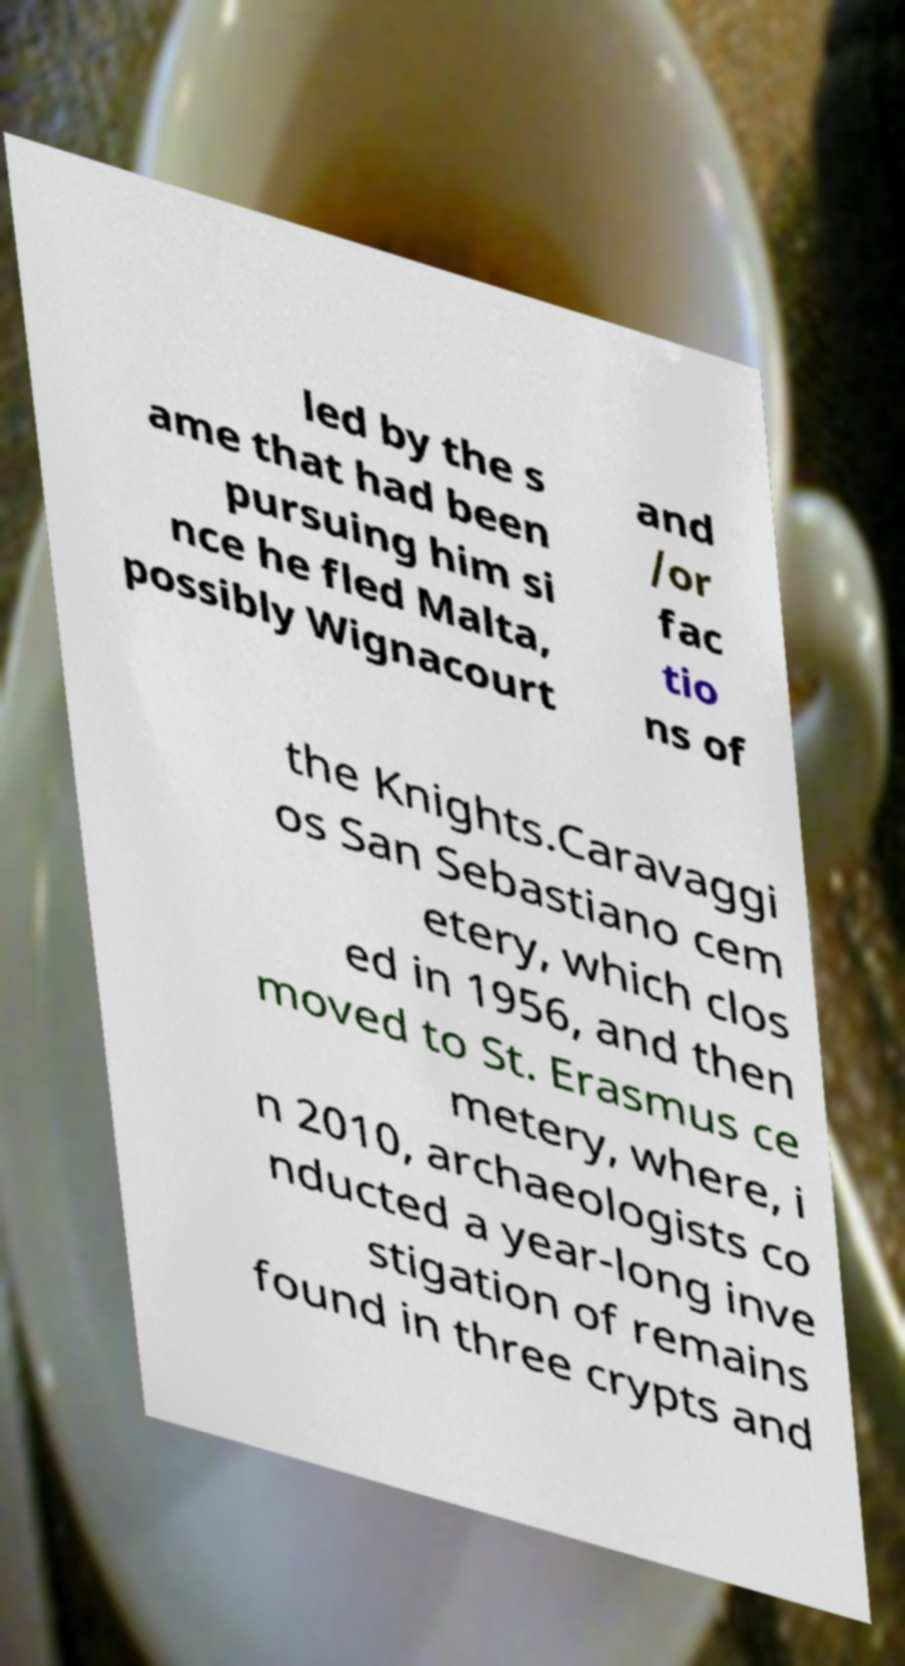Could you extract and type out the text from this image? led by the s ame that had been pursuing him si nce he fled Malta, possibly Wignacourt and /or fac tio ns of the Knights.Caravaggi os San Sebastiano cem etery, which clos ed in 1956, and then moved to St. Erasmus ce metery, where, i n 2010, archaeologists co nducted a year-long inve stigation of remains found in three crypts and 